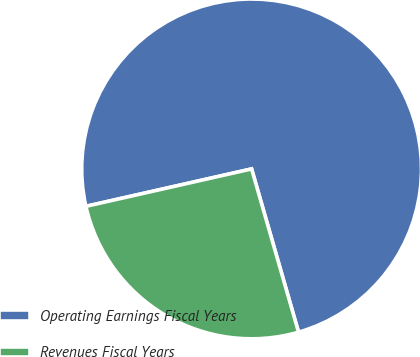Convert chart to OTSL. <chart><loc_0><loc_0><loc_500><loc_500><pie_chart><fcel>Operating Earnings Fiscal Years<fcel>Revenues Fiscal Years<nl><fcel>74.08%<fcel>25.92%<nl></chart> 